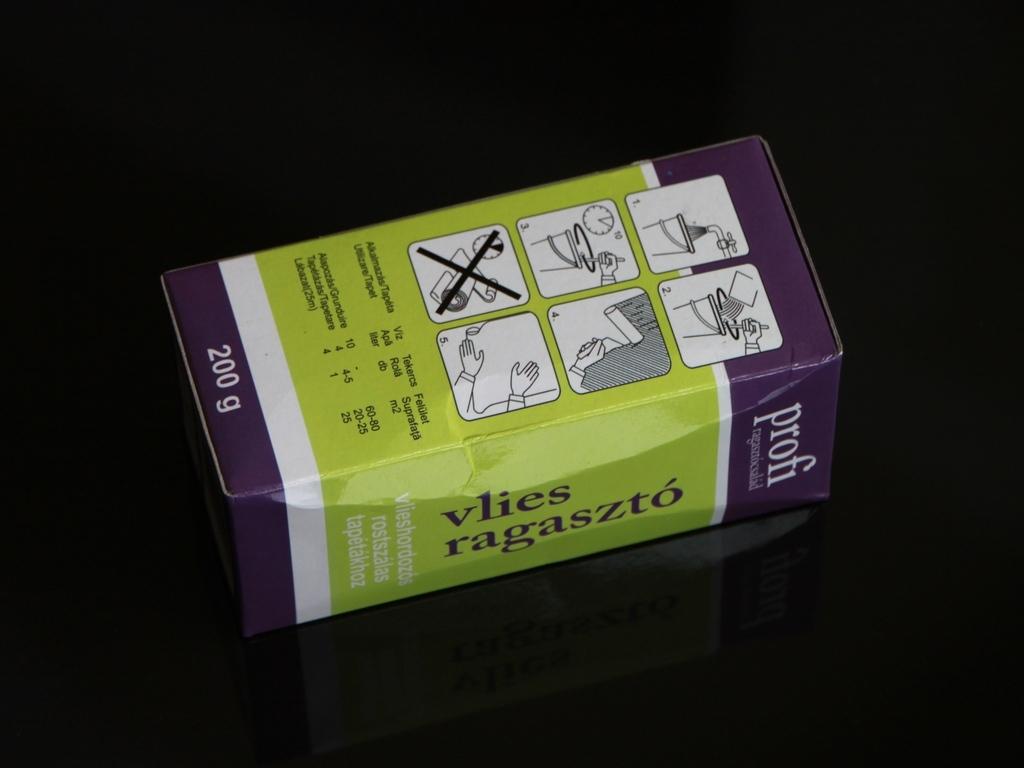Is this a syrup?
Provide a short and direct response. Unanswerable. What is the volume of the container?
Keep it short and to the point. 200g. 